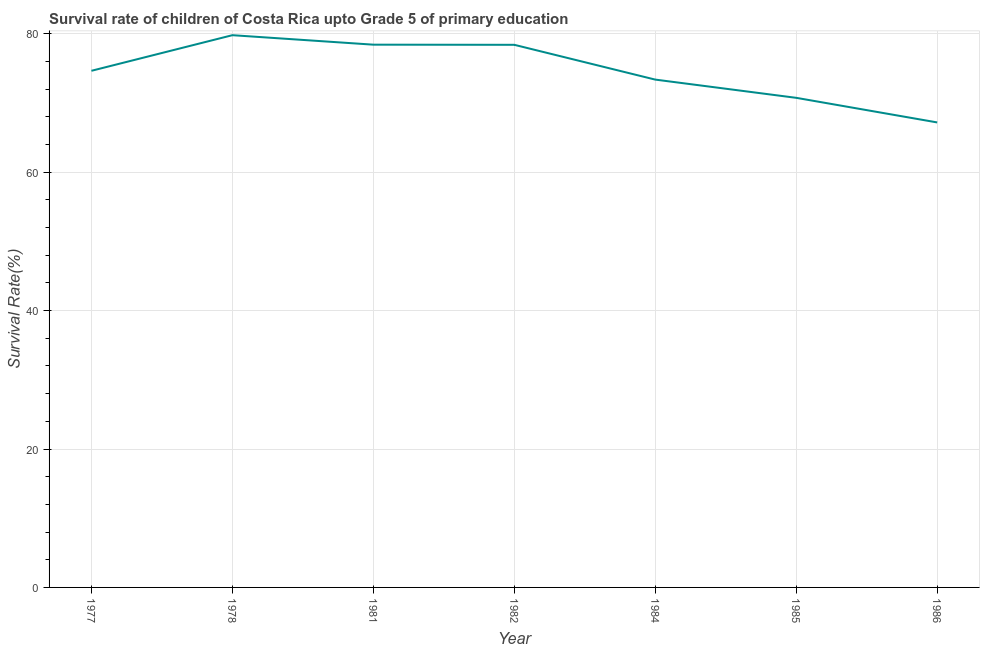What is the survival rate in 1977?
Make the answer very short. 74.65. Across all years, what is the maximum survival rate?
Keep it short and to the point. 79.79. Across all years, what is the minimum survival rate?
Ensure brevity in your answer.  67.19. In which year was the survival rate maximum?
Provide a succinct answer. 1978. What is the sum of the survival rate?
Offer a very short reply. 522.56. What is the difference between the survival rate in 1981 and 1986?
Ensure brevity in your answer.  11.23. What is the average survival rate per year?
Your answer should be very brief. 74.65. What is the median survival rate?
Keep it short and to the point. 74.65. Do a majority of the years between 1982 and 1984 (inclusive) have survival rate greater than 64 %?
Your answer should be compact. Yes. What is the ratio of the survival rate in 1978 to that in 1982?
Offer a very short reply. 1.02. Is the difference between the survival rate in 1978 and 1981 greater than the difference between any two years?
Ensure brevity in your answer.  No. What is the difference between the highest and the second highest survival rate?
Ensure brevity in your answer.  1.37. What is the difference between the highest and the lowest survival rate?
Your response must be concise. 12.61. In how many years, is the survival rate greater than the average survival rate taken over all years?
Offer a terse response. 3. Does the survival rate monotonically increase over the years?
Offer a terse response. No. How many lines are there?
Keep it short and to the point. 1. What is the difference between two consecutive major ticks on the Y-axis?
Make the answer very short. 20. Does the graph contain grids?
Give a very brief answer. Yes. What is the title of the graph?
Provide a succinct answer. Survival rate of children of Costa Rica upto Grade 5 of primary education. What is the label or title of the Y-axis?
Your response must be concise. Survival Rate(%). What is the Survival Rate(%) of 1977?
Ensure brevity in your answer.  74.65. What is the Survival Rate(%) of 1978?
Your response must be concise. 79.79. What is the Survival Rate(%) in 1981?
Ensure brevity in your answer.  78.42. What is the Survival Rate(%) in 1982?
Offer a very short reply. 78.4. What is the Survival Rate(%) in 1984?
Give a very brief answer. 73.37. What is the Survival Rate(%) of 1985?
Provide a succinct answer. 70.74. What is the Survival Rate(%) in 1986?
Your response must be concise. 67.19. What is the difference between the Survival Rate(%) in 1977 and 1978?
Give a very brief answer. -5.15. What is the difference between the Survival Rate(%) in 1977 and 1981?
Give a very brief answer. -3.78. What is the difference between the Survival Rate(%) in 1977 and 1982?
Offer a terse response. -3.75. What is the difference between the Survival Rate(%) in 1977 and 1984?
Make the answer very short. 1.27. What is the difference between the Survival Rate(%) in 1977 and 1985?
Provide a short and direct response. 3.91. What is the difference between the Survival Rate(%) in 1977 and 1986?
Offer a terse response. 7.46. What is the difference between the Survival Rate(%) in 1978 and 1981?
Your response must be concise. 1.37. What is the difference between the Survival Rate(%) in 1978 and 1982?
Offer a terse response. 1.39. What is the difference between the Survival Rate(%) in 1978 and 1984?
Your answer should be compact. 6.42. What is the difference between the Survival Rate(%) in 1978 and 1985?
Provide a short and direct response. 9.05. What is the difference between the Survival Rate(%) in 1978 and 1986?
Ensure brevity in your answer.  12.61. What is the difference between the Survival Rate(%) in 1981 and 1982?
Your response must be concise. 0.02. What is the difference between the Survival Rate(%) in 1981 and 1984?
Ensure brevity in your answer.  5.05. What is the difference between the Survival Rate(%) in 1981 and 1985?
Provide a short and direct response. 7.68. What is the difference between the Survival Rate(%) in 1981 and 1986?
Make the answer very short. 11.23. What is the difference between the Survival Rate(%) in 1982 and 1984?
Offer a terse response. 5.03. What is the difference between the Survival Rate(%) in 1982 and 1985?
Ensure brevity in your answer.  7.66. What is the difference between the Survival Rate(%) in 1982 and 1986?
Offer a very short reply. 11.21. What is the difference between the Survival Rate(%) in 1984 and 1985?
Offer a very short reply. 2.63. What is the difference between the Survival Rate(%) in 1984 and 1986?
Provide a short and direct response. 6.19. What is the difference between the Survival Rate(%) in 1985 and 1986?
Your response must be concise. 3.55. What is the ratio of the Survival Rate(%) in 1977 to that in 1978?
Make the answer very short. 0.94. What is the ratio of the Survival Rate(%) in 1977 to that in 1981?
Provide a succinct answer. 0.95. What is the ratio of the Survival Rate(%) in 1977 to that in 1982?
Provide a succinct answer. 0.95. What is the ratio of the Survival Rate(%) in 1977 to that in 1984?
Your response must be concise. 1.02. What is the ratio of the Survival Rate(%) in 1977 to that in 1985?
Offer a very short reply. 1.05. What is the ratio of the Survival Rate(%) in 1977 to that in 1986?
Your answer should be compact. 1.11. What is the ratio of the Survival Rate(%) in 1978 to that in 1981?
Offer a very short reply. 1.02. What is the ratio of the Survival Rate(%) in 1978 to that in 1984?
Give a very brief answer. 1.09. What is the ratio of the Survival Rate(%) in 1978 to that in 1985?
Ensure brevity in your answer.  1.13. What is the ratio of the Survival Rate(%) in 1978 to that in 1986?
Provide a short and direct response. 1.19. What is the ratio of the Survival Rate(%) in 1981 to that in 1984?
Offer a very short reply. 1.07. What is the ratio of the Survival Rate(%) in 1981 to that in 1985?
Your answer should be compact. 1.11. What is the ratio of the Survival Rate(%) in 1981 to that in 1986?
Your response must be concise. 1.17. What is the ratio of the Survival Rate(%) in 1982 to that in 1984?
Give a very brief answer. 1.07. What is the ratio of the Survival Rate(%) in 1982 to that in 1985?
Your response must be concise. 1.11. What is the ratio of the Survival Rate(%) in 1982 to that in 1986?
Your answer should be very brief. 1.17. What is the ratio of the Survival Rate(%) in 1984 to that in 1985?
Keep it short and to the point. 1.04. What is the ratio of the Survival Rate(%) in 1984 to that in 1986?
Give a very brief answer. 1.09. What is the ratio of the Survival Rate(%) in 1985 to that in 1986?
Provide a succinct answer. 1.05. 